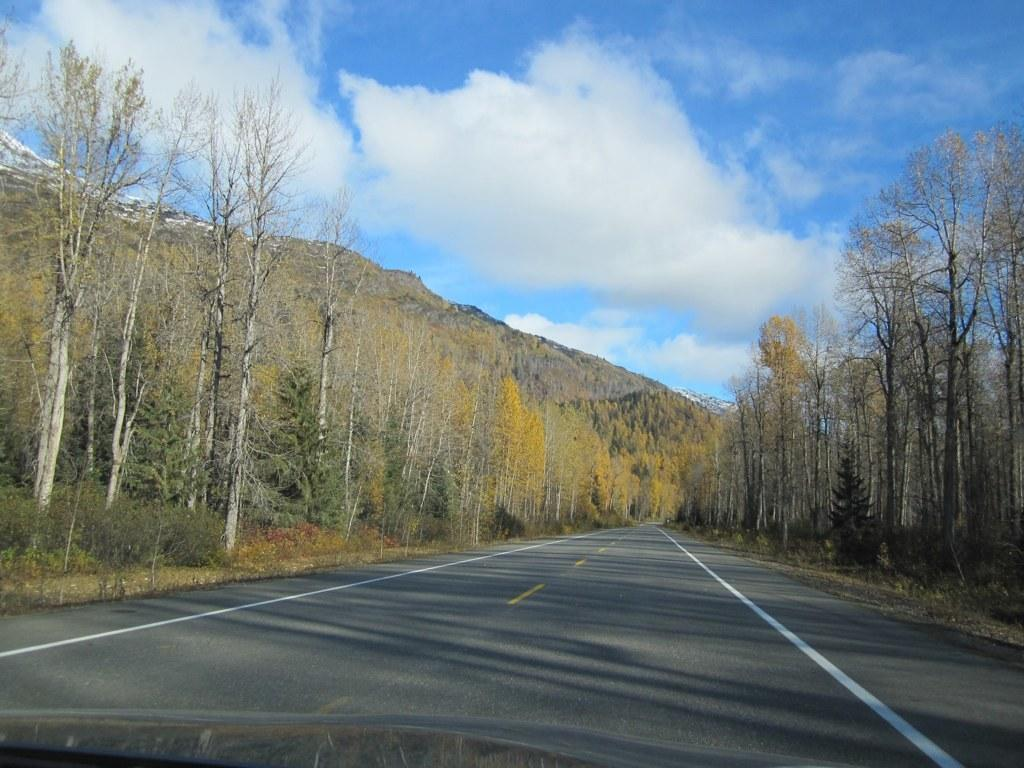What type of natural features can be seen in the image? There are trees and mountains in the image. What man-made feature is present in the image? There is a road in the image. How would you describe the sky in the image? The sky is cloudy in the image. What type of lunch is being served in the image? There is no lunch present in the image; it features trees, mountains, a road, and a cloudy sky. What emotion can be seen on the trees' faces in the image? Trees do not have faces or emotions, so this question cannot be answered. 